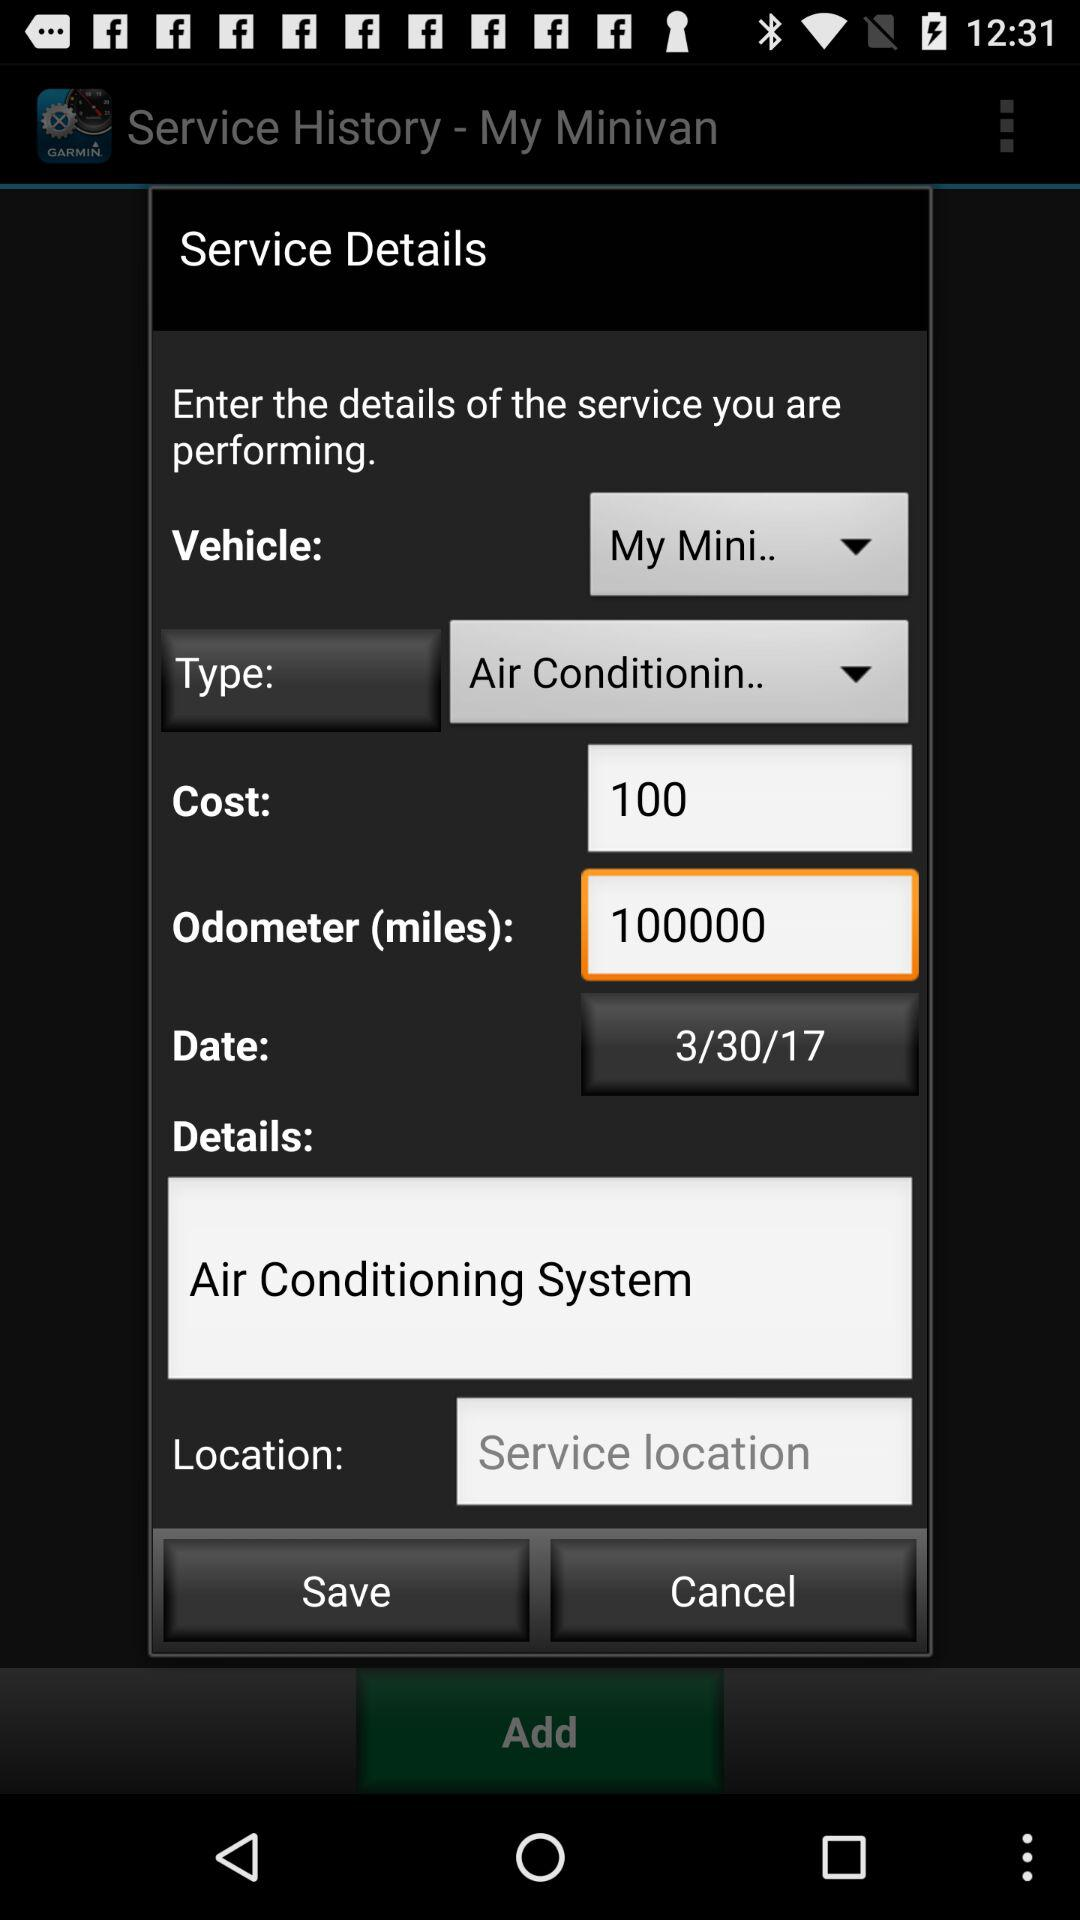What is the "Odometer" reading in miles? The odometer reading is 100,000 miles. 